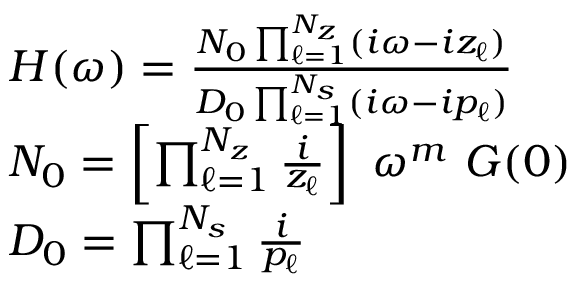<formula> <loc_0><loc_0><loc_500><loc_500>\begin{array} { r } { \begin{array} { r l } & { H ( \omega ) = \frac { N _ { 0 } \prod _ { \ell = 1 } ^ { N _ { z } } ( i \omega - i z _ { \ell } ) } { D _ { 0 } \prod _ { \ell = 1 } ^ { N _ { s } } ( i \omega - i p _ { \ell } ) } } \\ & { N _ { 0 } = \left [ \prod _ { \ell = 1 } ^ { N _ { z } } \frac { i } { z _ { \ell } } \right ] \omega ^ { m } G ( 0 ) } \\ & { D _ { 0 } = \prod _ { \ell = 1 } ^ { N _ { s } } \frac { i } { p _ { \ell } } } \end{array} } \end{array}</formula> 